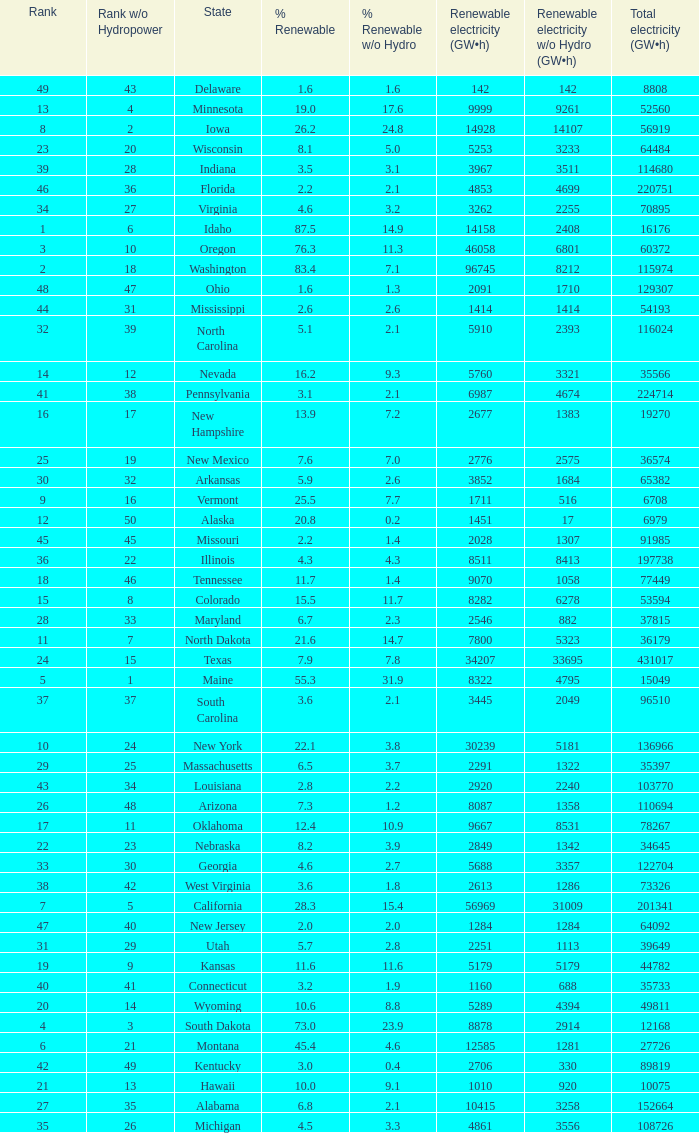When renewable electricity is 5760 (gw×h) what is the minimum amount of renewable elecrrixity without hydrogen power? 3321.0. 